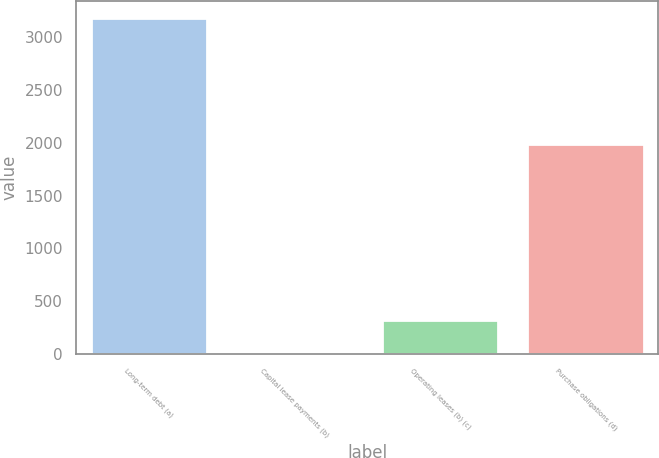<chart> <loc_0><loc_0><loc_500><loc_500><bar_chart><fcel>Long-term debt (a)<fcel>Capital lease payments (b)<fcel>Operating leases (b) (c)<fcel>Purchase obligations (d)<nl><fcel>3187<fcel>6<fcel>324.1<fcel>1992<nl></chart> 